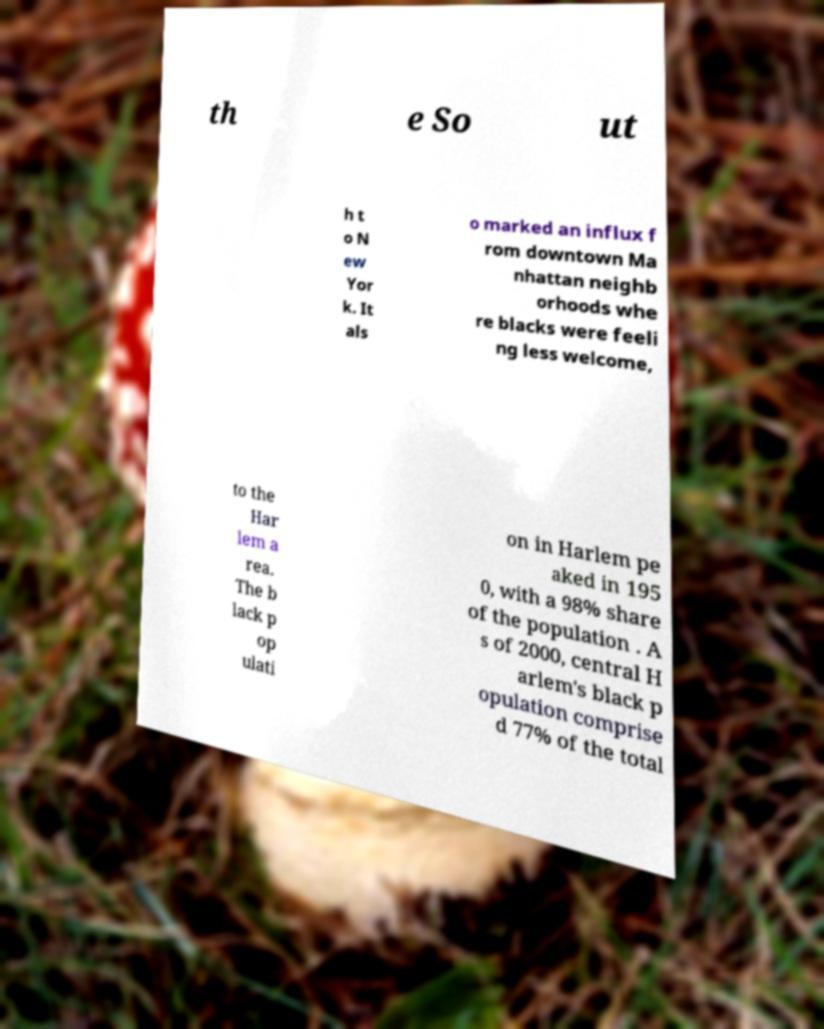Please identify and transcribe the text found in this image. th e So ut h t o N ew Yor k. It als o marked an influx f rom downtown Ma nhattan neighb orhoods whe re blacks were feeli ng less welcome, to the Har lem a rea. The b lack p op ulati on in Harlem pe aked in 195 0, with a 98% share of the population . A s of 2000, central H arlem's black p opulation comprise d 77% of the total 